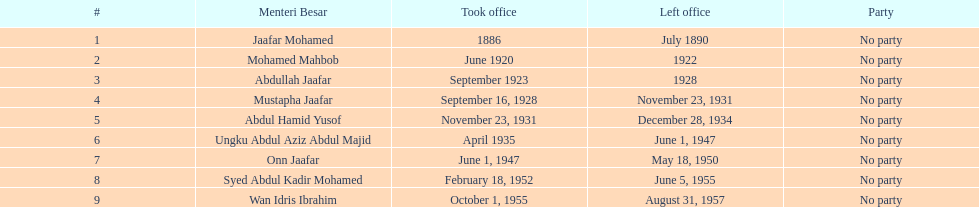Who took office after abdullah jaafar? Mustapha Jaafar. 